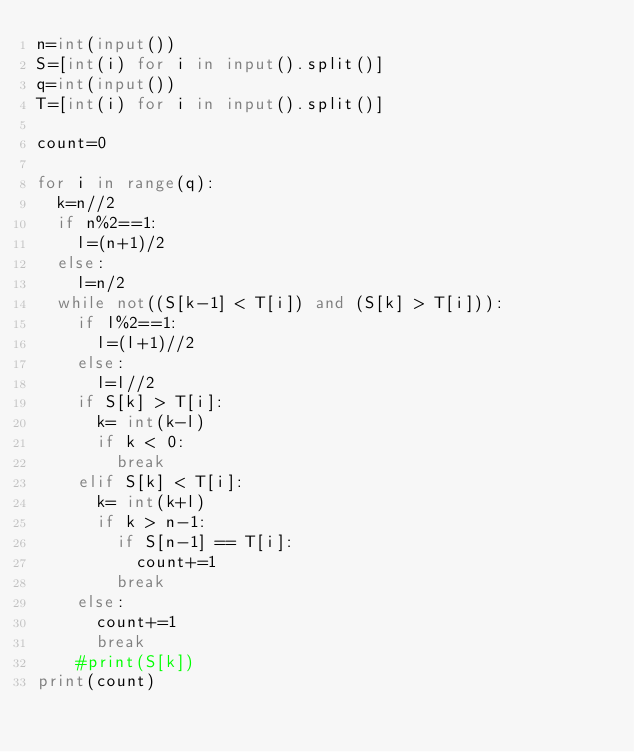Convert code to text. <code><loc_0><loc_0><loc_500><loc_500><_Python_>n=int(input())
S=[int(i) for i in input().split()]
q=int(input())
T=[int(i) for i in input().split()]

count=0

for i in range(q):
  k=n//2
  if n%2==1:
    l=(n+1)/2
  else:
    l=n/2
  while not((S[k-1] < T[i]) and (S[k] > T[i])):
    if l%2==1:
      l=(l+1)//2
    else:
      l=l//2
    if S[k] > T[i]:
      k= int(k-l)
      if k < 0:
        break
    elif S[k] < T[i]:
      k= int(k+l)
      if k > n-1:
        if S[n-1] == T[i]:
          count+=1
        break
    else:
      count+=1
      break
    #print(S[k])
print(count)
</code> 